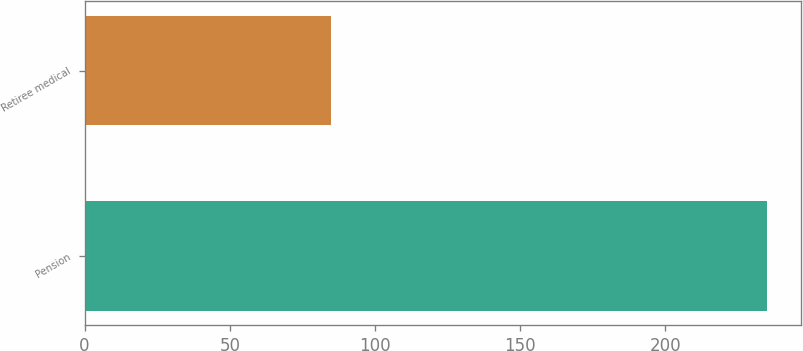<chart> <loc_0><loc_0><loc_500><loc_500><bar_chart><fcel>Pension<fcel>Retiree medical<nl><fcel>235<fcel>85<nl></chart> 